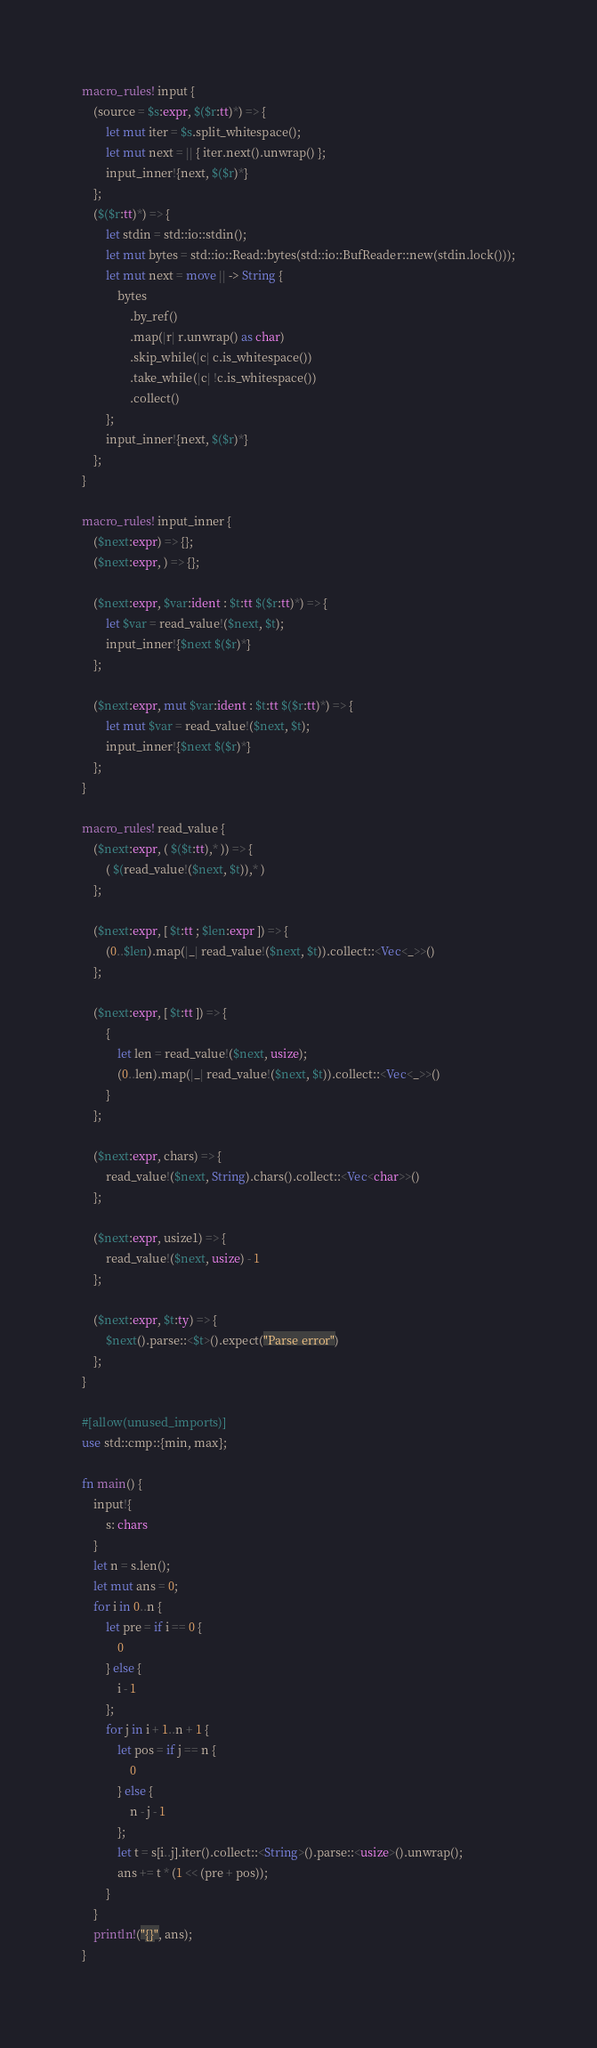Convert code to text. <code><loc_0><loc_0><loc_500><loc_500><_Rust_>macro_rules! input {
    (source = $s:expr, $($r:tt)*) => {
        let mut iter = $s.split_whitespace();
        let mut next = || { iter.next().unwrap() };
        input_inner!{next, $($r)*}
    };
    ($($r:tt)*) => {
        let stdin = std::io::stdin();
        let mut bytes = std::io::Read::bytes(std::io::BufReader::new(stdin.lock()));
        let mut next = move || -> String {
            bytes
                .by_ref()
                .map(|r| r.unwrap() as char)
                .skip_while(|c| c.is_whitespace())
                .take_while(|c| !c.is_whitespace())
                .collect()
        };
        input_inner!{next, $($r)*}
    };
}

macro_rules! input_inner {
    ($next:expr) => {};
    ($next:expr, ) => {};

    ($next:expr, $var:ident : $t:tt $($r:tt)*) => {
        let $var = read_value!($next, $t);
        input_inner!{$next $($r)*}
    };

    ($next:expr, mut $var:ident : $t:tt $($r:tt)*) => {
        let mut $var = read_value!($next, $t);
        input_inner!{$next $($r)*}
    };
}

macro_rules! read_value {
    ($next:expr, ( $($t:tt),* )) => {
        ( $(read_value!($next, $t)),* )
    };

    ($next:expr, [ $t:tt ; $len:expr ]) => {
        (0..$len).map(|_| read_value!($next, $t)).collect::<Vec<_>>()
    };

    ($next:expr, [ $t:tt ]) => {
        {
            let len = read_value!($next, usize);
            (0..len).map(|_| read_value!($next, $t)).collect::<Vec<_>>()
        }
    };

    ($next:expr, chars) => {
        read_value!($next, String).chars().collect::<Vec<char>>()
    };

    ($next:expr, usize1) => {
        read_value!($next, usize) - 1
    };

    ($next:expr, $t:ty) => {
        $next().parse::<$t>().expect("Parse error")
    };
}

#[allow(unused_imports)]
use std::cmp::{min, max};

fn main() {
    input!{
        s: chars
    }
    let n = s.len();
    let mut ans = 0;
    for i in 0..n {
        let pre = if i == 0 {
            0
        } else {
            i - 1
        };
        for j in i + 1..n + 1 {
            let pos = if j == n {
                0
            } else {
                n - j - 1
            };
            let t = s[i..j].iter().collect::<String>().parse::<usize>().unwrap();
            ans += t * (1 << (pre + pos));
        }
    }
    println!("{}", ans);
}
</code> 